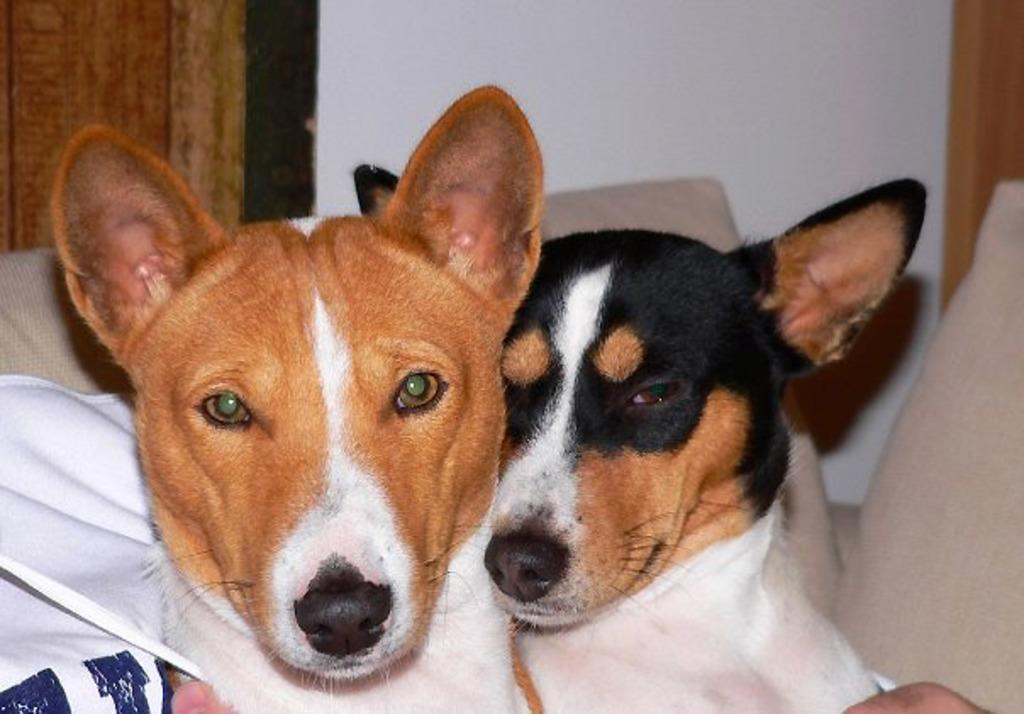What is the person in the image doing? The person is sitting on a sofa in the image. What is the person holding in the image? The person is holding dogs in the image. What can be seen on the sofa besides the person? There are cushions visible in the image. What is the background of the image? There is a wall in the image. Can you see any grass or stream in the image? No, there is no grass or stream present in the image. 